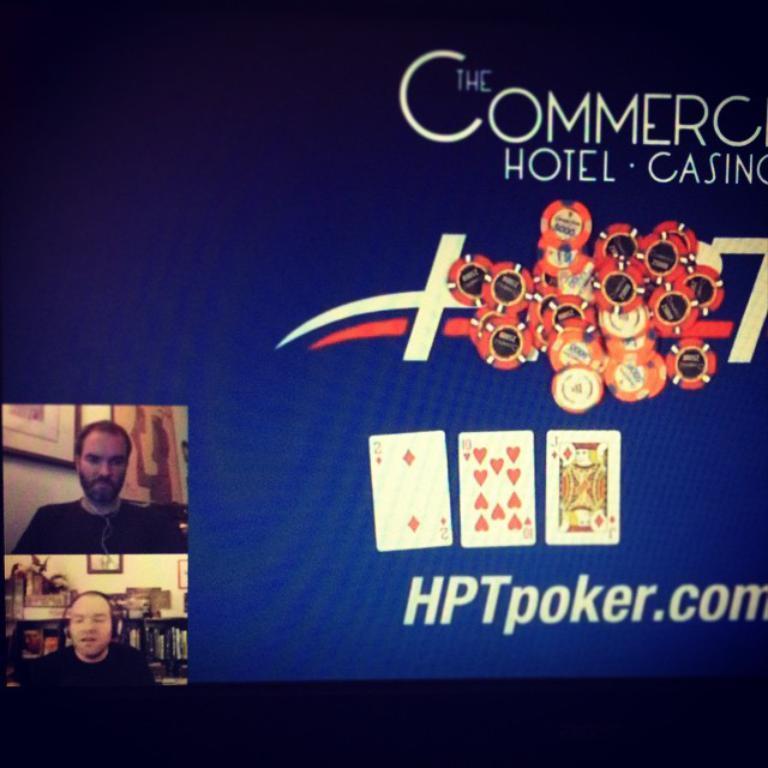Can you describe this image briefly? In this image we can see the display screen with the text, coins, cards and also the people. 